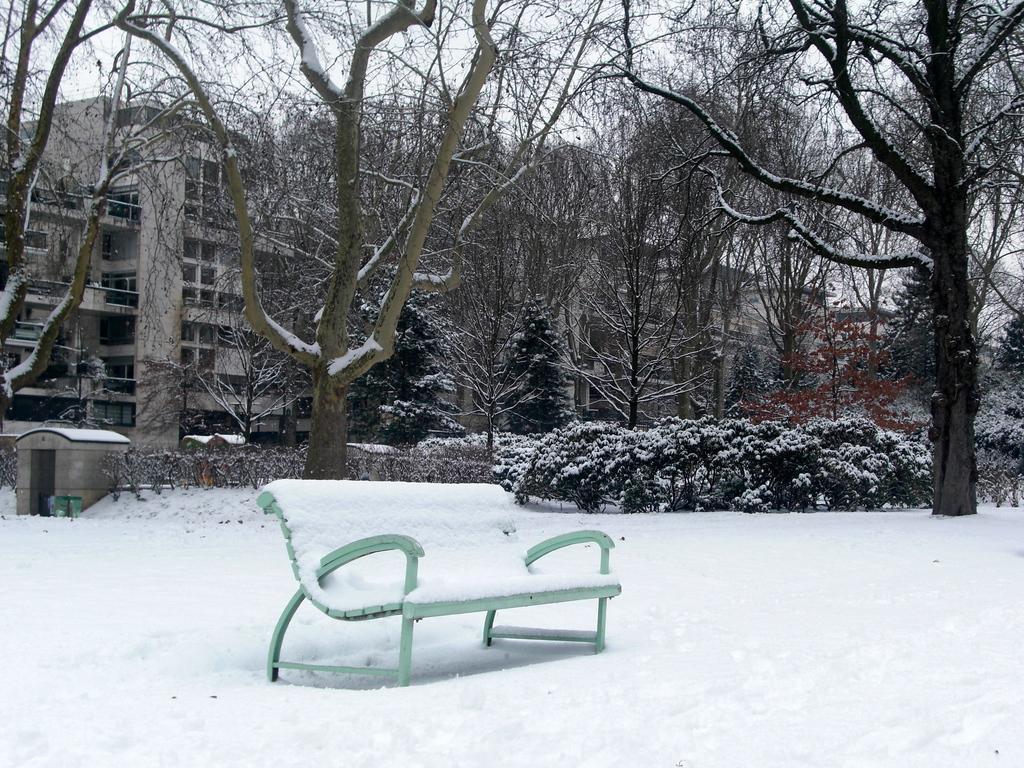Describe this image in one or two sentences. In the picture we can see a snowy surface on it we can see a bench with some snow on it and in the background we can see some plants, trees, and behind it we can see a building and behind it we can see a sky. 